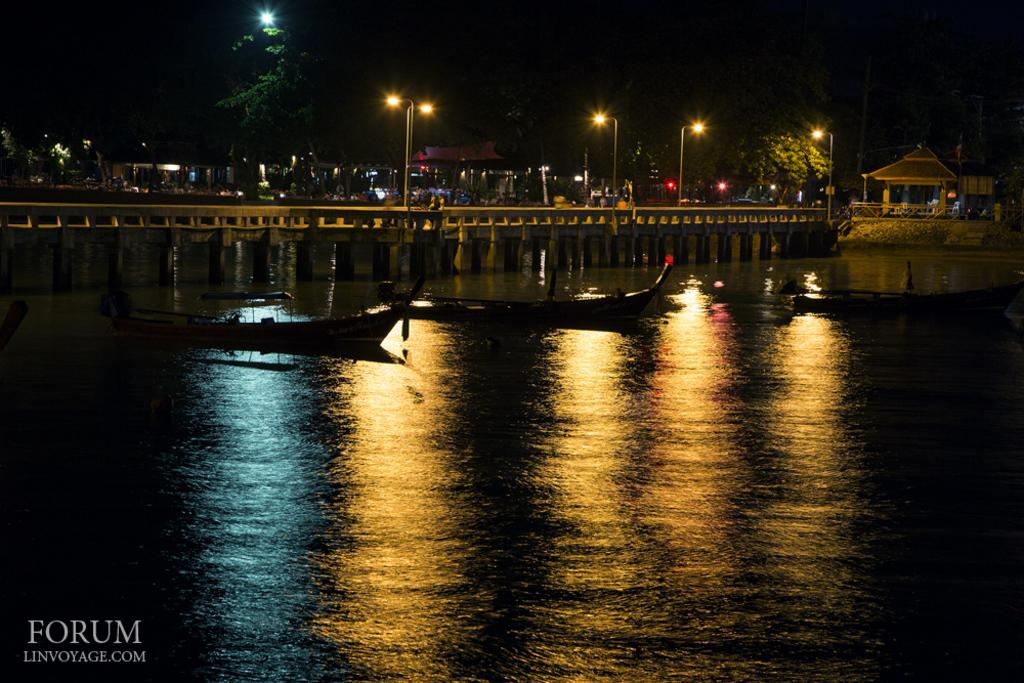What body of water is present in the image? There is a river in the image. What is on the river in the image? There are two boats on the river. What structure is in the center of the image? There is a bridge with poles in the center of the image. What can be seen in the background of the image? There are buildings, trees, and the sky visible in the background of the image. How many suns are visible in the image? There is only one sun visible in the image, as it is a celestial body and cannot be duplicated. 